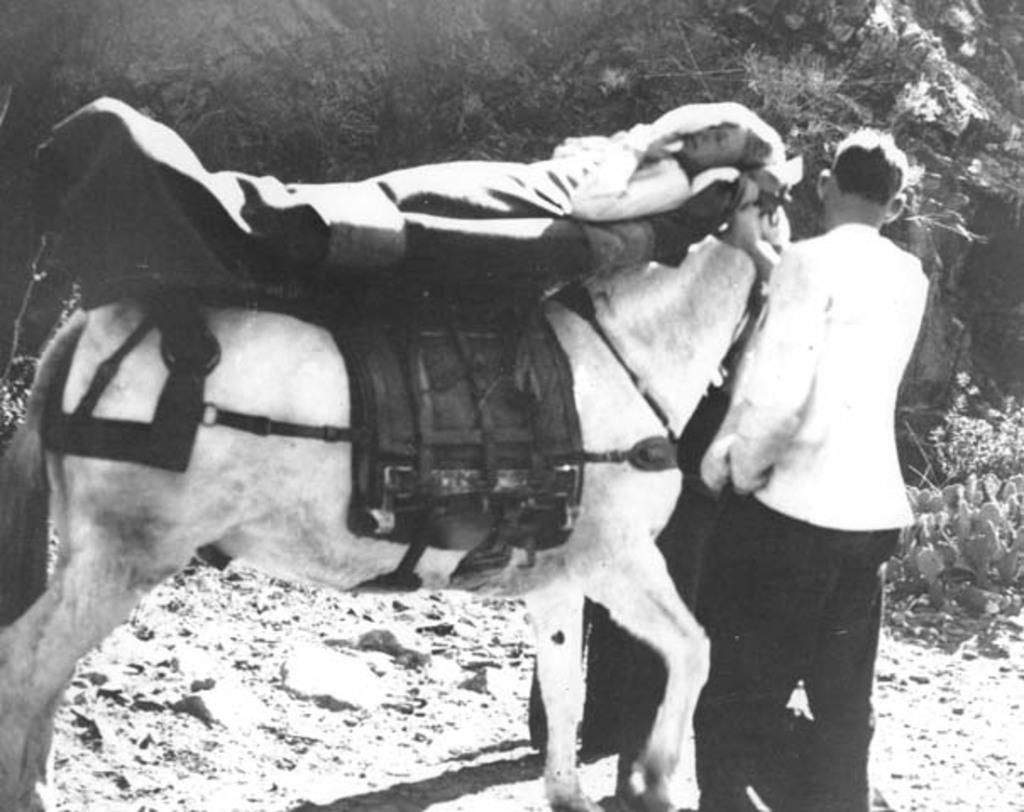What is happening in the center of the image? There is a person lying on a horse in the center of the image. What is the man on the right side of the image doing? There is a man standing on the right side of the image. What can be seen in the background of the image? There are trees, plants, and a stone in the background of the image. Where is the faucet located in the image? There is no faucet present in the image. What type of roll is being used by the person lying on the horse? The person lying on the horse is not using any roll in the image. 